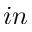<formula> <loc_0><loc_0><loc_500><loc_500>i n</formula> 